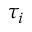<formula> <loc_0><loc_0><loc_500><loc_500>\tau _ { i }</formula> 